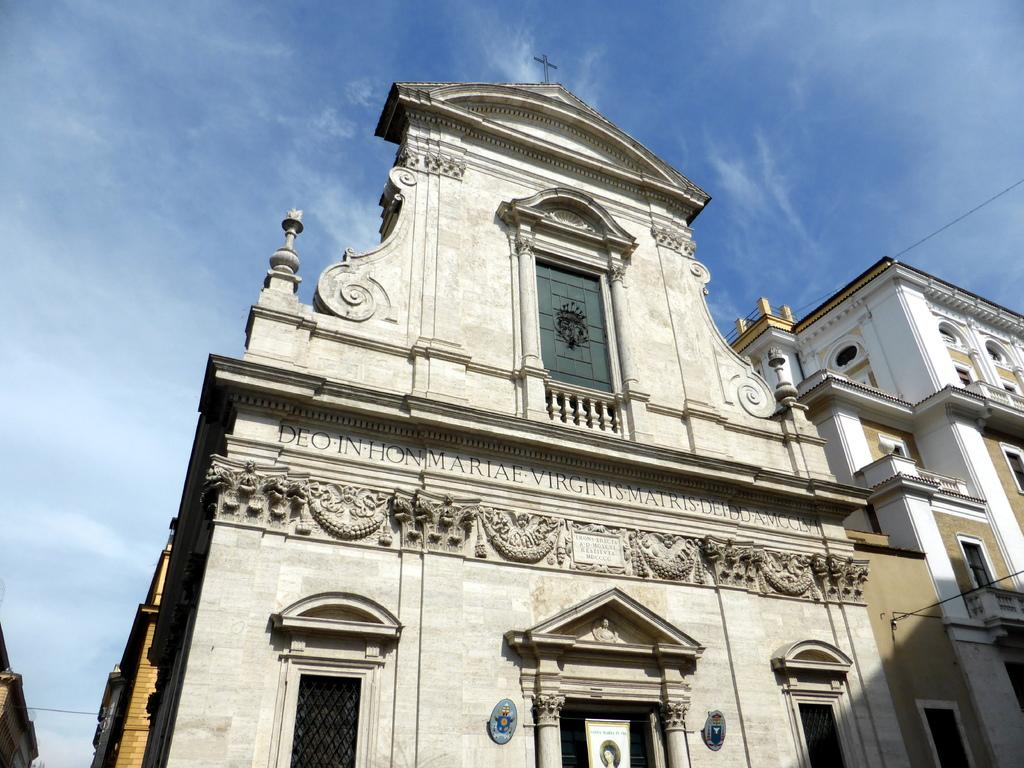What type of structures can be seen in the image? There are buildings in the image. What feature do the buildings have? The buildings have windows. What can be seen in the background of the image? The sky is visible in the background of the image. Where are the flowers growing in the image? There are no flowers present in the image. What type of yoke is being used by the people in the image? There are no people or yokes present in the image. 